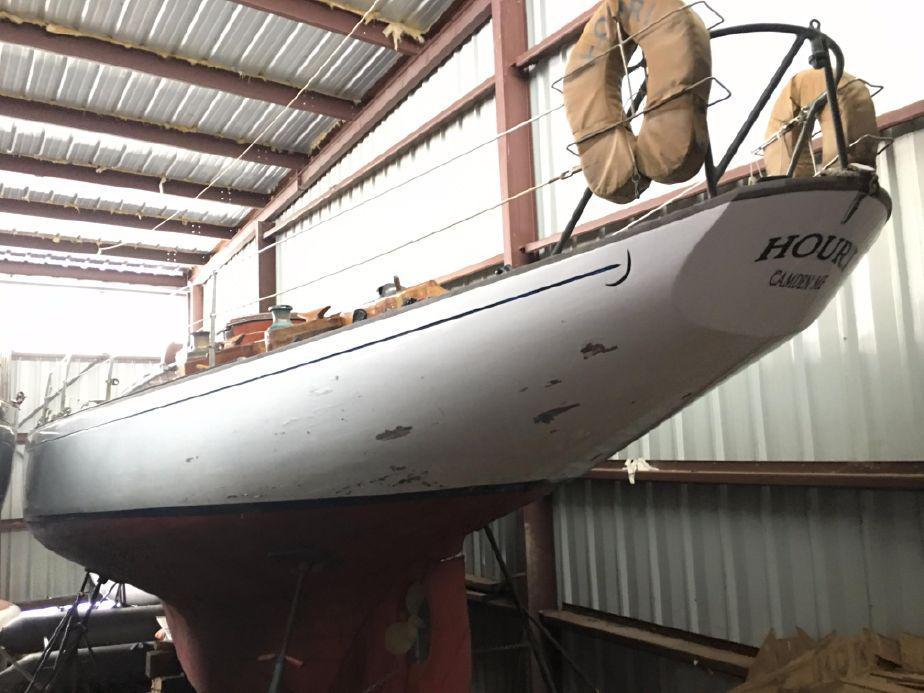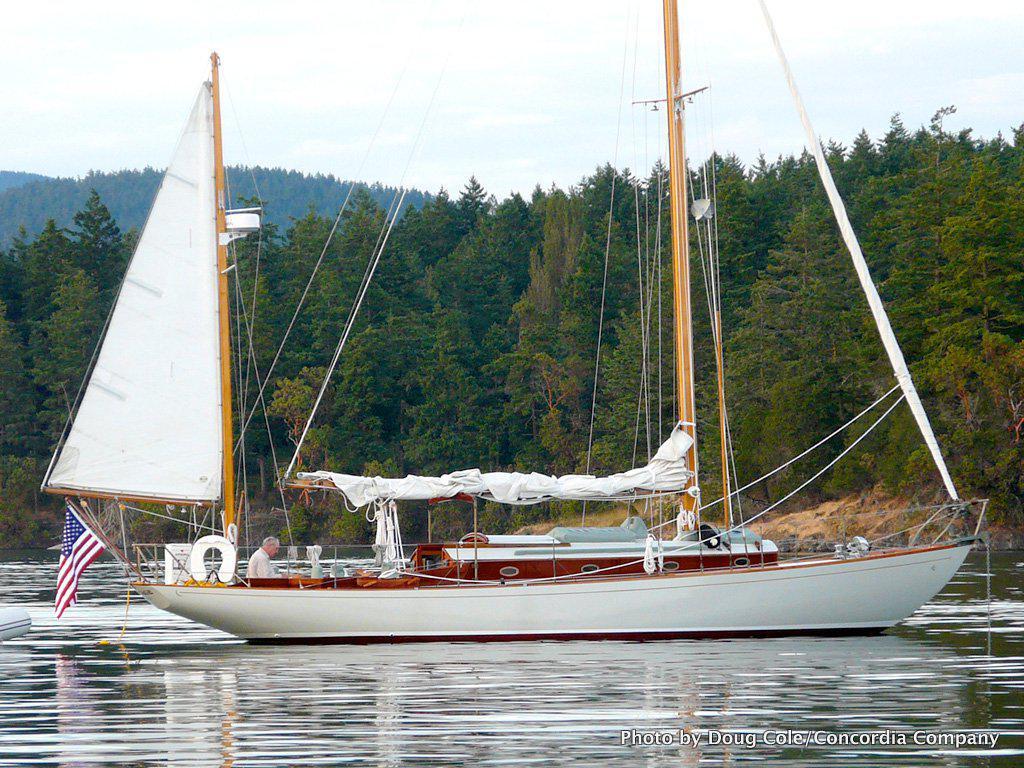The first image is the image on the left, the second image is the image on the right. Analyze the images presented: Is the assertion "The left and right image contains the same number of  sailboats in the water." valid? Answer yes or no. No. 